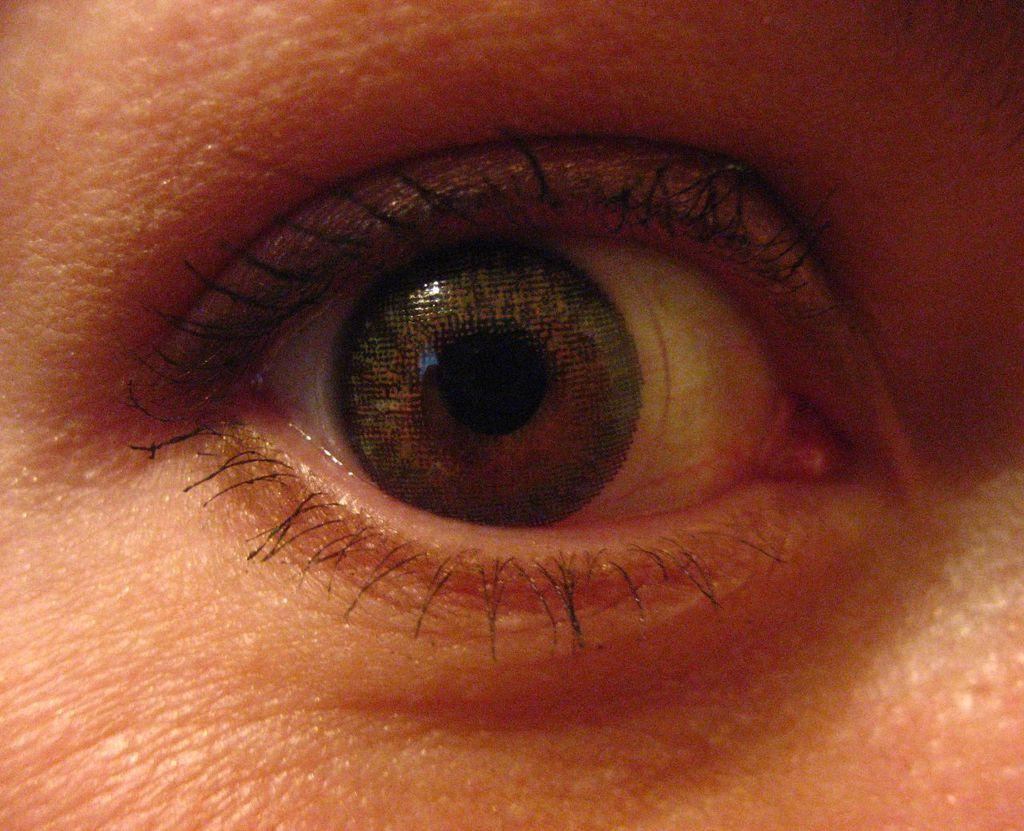What is the main subject of the image? The main subject of the image is a person's eye. Can you describe any specific features of the eye in the image? Unfortunately, the provided facts do not include any specific features of the eye. Is there anything else visible in the image besides the eye? The provided facts do not mention any other objects or subjects in the image. What type of shade is covering the carriage in the image? There is no shade or carriage present in the image; it only features a person's eye. How many hydrants are visible in the image? There are no hydrants present in the image; it only features a person's eye. 